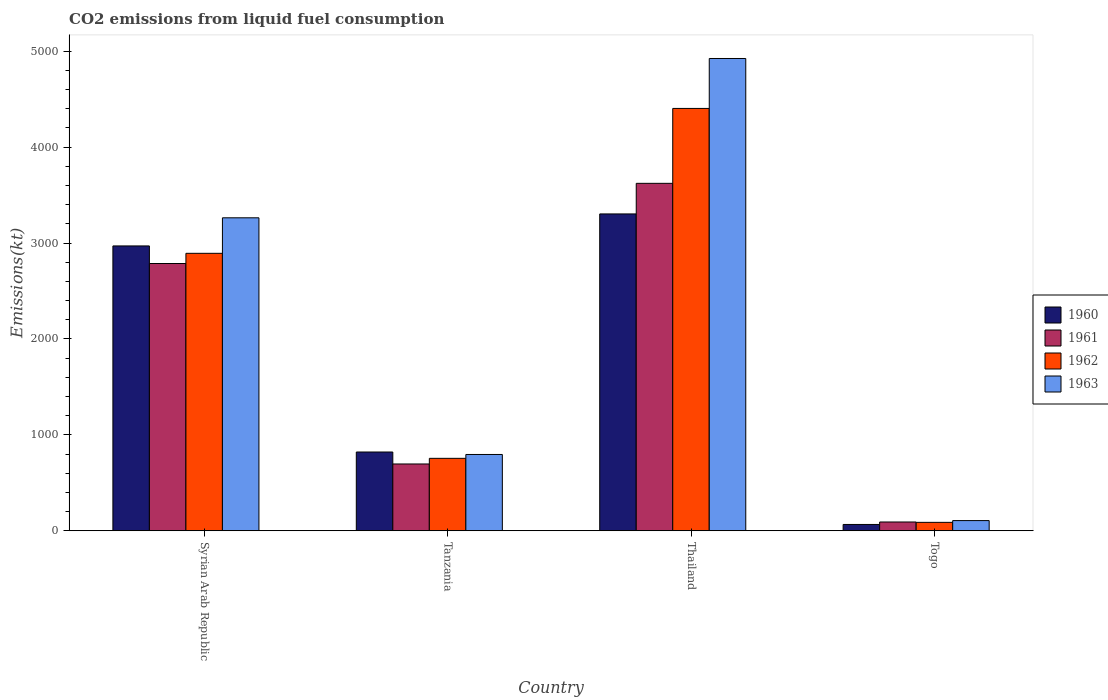How many different coloured bars are there?
Your response must be concise. 4. How many bars are there on the 1st tick from the left?
Your response must be concise. 4. What is the label of the 2nd group of bars from the left?
Provide a succinct answer. Tanzania. In how many cases, is the number of bars for a given country not equal to the number of legend labels?
Your answer should be very brief. 0. What is the amount of CO2 emitted in 1962 in Syrian Arab Republic?
Give a very brief answer. 2893.26. Across all countries, what is the maximum amount of CO2 emitted in 1963?
Your answer should be very brief. 4924.78. Across all countries, what is the minimum amount of CO2 emitted in 1962?
Make the answer very short. 88.01. In which country was the amount of CO2 emitted in 1960 maximum?
Provide a short and direct response. Thailand. In which country was the amount of CO2 emitted in 1962 minimum?
Make the answer very short. Togo. What is the total amount of CO2 emitted in 1960 in the graph?
Provide a succinct answer. 7161.65. What is the difference between the amount of CO2 emitted in 1961 in Syrian Arab Republic and that in Tanzania?
Provide a succinct answer. 2090.19. What is the difference between the amount of CO2 emitted in 1962 in Tanzania and the amount of CO2 emitted in 1963 in Syrian Arab Republic?
Offer a very short reply. -2508.23. What is the average amount of CO2 emitted in 1960 per country?
Offer a terse response. 1790.41. What is the difference between the amount of CO2 emitted of/in 1962 and amount of CO2 emitted of/in 1963 in Thailand?
Ensure brevity in your answer.  -520.71. In how many countries, is the amount of CO2 emitted in 1963 greater than 4000 kt?
Give a very brief answer. 1. What is the ratio of the amount of CO2 emitted in 1960 in Tanzania to that in Togo?
Offer a terse response. 12.44. Is the amount of CO2 emitted in 1961 in Syrian Arab Republic less than that in Thailand?
Your answer should be compact. Yes. What is the difference between the highest and the second highest amount of CO2 emitted in 1962?
Offer a very short reply. -3648.66. What is the difference between the highest and the lowest amount of CO2 emitted in 1961?
Offer a very short reply. 3531.32. What does the 4th bar from the left in Tanzania represents?
Keep it short and to the point. 1963. What is the difference between two consecutive major ticks on the Y-axis?
Provide a succinct answer. 1000. Are the values on the major ticks of Y-axis written in scientific E-notation?
Give a very brief answer. No. Does the graph contain any zero values?
Offer a very short reply. No. Where does the legend appear in the graph?
Your answer should be compact. Center right. How are the legend labels stacked?
Your answer should be very brief. Vertical. What is the title of the graph?
Your response must be concise. CO2 emissions from liquid fuel consumption. What is the label or title of the Y-axis?
Your answer should be compact. Emissions(kt). What is the Emissions(kt) of 1960 in Syrian Arab Republic?
Keep it short and to the point. 2970.27. What is the Emissions(kt) in 1961 in Syrian Arab Republic?
Ensure brevity in your answer.  2786.92. What is the Emissions(kt) in 1962 in Syrian Arab Republic?
Keep it short and to the point. 2893.26. What is the Emissions(kt) in 1963 in Syrian Arab Republic?
Offer a terse response. 3263.63. What is the Emissions(kt) of 1960 in Tanzania?
Offer a terse response. 821.41. What is the Emissions(kt) in 1961 in Tanzania?
Offer a terse response. 696.73. What is the Emissions(kt) of 1962 in Tanzania?
Offer a terse response. 755.4. What is the Emissions(kt) in 1963 in Tanzania?
Provide a short and direct response. 795.74. What is the Emissions(kt) in 1960 in Thailand?
Offer a terse response. 3303.97. What is the Emissions(kt) in 1961 in Thailand?
Keep it short and to the point. 3623. What is the Emissions(kt) of 1962 in Thailand?
Provide a short and direct response. 4404.07. What is the Emissions(kt) in 1963 in Thailand?
Keep it short and to the point. 4924.78. What is the Emissions(kt) of 1960 in Togo?
Your answer should be very brief. 66.01. What is the Emissions(kt) of 1961 in Togo?
Make the answer very short. 91.67. What is the Emissions(kt) in 1962 in Togo?
Your answer should be compact. 88.01. What is the Emissions(kt) in 1963 in Togo?
Offer a terse response. 106.34. Across all countries, what is the maximum Emissions(kt) in 1960?
Keep it short and to the point. 3303.97. Across all countries, what is the maximum Emissions(kt) of 1961?
Give a very brief answer. 3623. Across all countries, what is the maximum Emissions(kt) in 1962?
Offer a terse response. 4404.07. Across all countries, what is the maximum Emissions(kt) in 1963?
Make the answer very short. 4924.78. Across all countries, what is the minimum Emissions(kt) in 1960?
Make the answer very short. 66.01. Across all countries, what is the minimum Emissions(kt) of 1961?
Offer a terse response. 91.67. Across all countries, what is the minimum Emissions(kt) of 1962?
Make the answer very short. 88.01. Across all countries, what is the minimum Emissions(kt) of 1963?
Offer a very short reply. 106.34. What is the total Emissions(kt) of 1960 in the graph?
Make the answer very short. 7161.65. What is the total Emissions(kt) of 1961 in the graph?
Make the answer very short. 7198.32. What is the total Emissions(kt) of 1962 in the graph?
Provide a succinct answer. 8140.74. What is the total Emissions(kt) in 1963 in the graph?
Offer a terse response. 9090.49. What is the difference between the Emissions(kt) of 1960 in Syrian Arab Republic and that in Tanzania?
Your answer should be very brief. 2148.86. What is the difference between the Emissions(kt) in 1961 in Syrian Arab Republic and that in Tanzania?
Ensure brevity in your answer.  2090.19. What is the difference between the Emissions(kt) of 1962 in Syrian Arab Republic and that in Tanzania?
Your response must be concise. 2137.86. What is the difference between the Emissions(kt) in 1963 in Syrian Arab Republic and that in Tanzania?
Your answer should be very brief. 2467.89. What is the difference between the Emissions(kt) in 1960 in Syrian Arab Republic and that in Thailand?
Ensure brevity in your answer.  -333.7. What is the difference between the Emissions(kt) in 1961 in Syrian Arab Republic and that in Thailand?
Provide a short and direct response. -836.08. What is the difference between the Emissions(kt) of 1962 in Syrian Arab Republic and that in Thailand?
Offer a very short reply. -1510.8. What is the difference between the Emissions(kt) of 1963 in Syrian Arab Republic and that in Thailand?
Keep it short and to the point. -1661.15. What is the difference between the Emissions(kt) of 1960 in Syrian Arab Republic and that in Togo?
Provide a succinct answer. 2904.26. What is the difference between the Emissions(kt) of 1961 in Syrian Arab Republic and that in Togo?
Your answer should be very brief. 2695.24. What is the difference between the Emissions(kt) in 1962 in Syrian Arab Republic and that in Togo?
Keep it short and to the point. 2805.26. What is the difference between the Emissions(kt) of 1963 in Syrian Arab Republic and that in Togo?
Your answer should be compact. 3157.29. What is the difference between the Emissions(kt) in 1960 in Tanzania and that in Thailand?
Provide a succinct answer. -2482.56. What is the difference between the Emissions(kt) of 1961 in Tanzania and that in Thailand?
Keep it short and to the point. -2926.27. What is the difference between the Emissions(kt) of 1962 in Tanzania and that in Thailand?
Provide a short and direct response. -3648.66. What is the difference between the Emissions(kt) in 1963 in Tanzania and that in Thailand?
Offer a terse response. -4129.04. What is the difference between the Emissions(kt) in 1960 in Tanzania and that in Togo?
Keep it short and to the point. 755.4. What is the difference between the Emissions(kt) of 1961 in Tanzania and that in Togo?
Provide a succinct answer. 605.05. What is the difference between the Emissions(kt) of 1962 in Tanzania and that in Togo?
Keep it short and to the point. 667.39. What is the difference between the Emissions(kt) in 1963 in Tanzania and that in Togo?
Your answer should be compact. 689.4. What is the difference between the Emissions(kt) of 1960 in Thailand and that in Togo?
Make the answer very short. 3237.96. What is the difference between the Emissions(kt) of 1961 in Thailand and that in Togo?
Your answer should be compact. 3531.32. What is the difference between the Emissions(kt) in 1962 in Thailand and that in Togo?
Your answer should be very brief. 4316.06. What is the difference between the Emissions(kt) of 1963 in Thailand and that in Togo?
Ensure brevity in your answer.  4818.44. What is the difference between the Emissions(kt) in 1960 in Syrian Arab Republic and the Emissions(kt) in 1961 in Tanzania?
Offer a terse response. 2273.54. What is the difference between the Emissions(kt) in 1960 in Syrian Arab Republic and the Emissions(kt) in 1962 in Tanzania?
Offer a very short reply. 2214.87. What is the difference between the Emissions(kt) of 1960 in Syrian Arab Republic and the Emissions(kt) of 1963 in Tanzania?
Offer a terse response. 2174.53. What is the difference between the Emissions(kt) in 1961 in Syrian Arab Republic and the Emissions(kt) in 1962 in Tanzania?
Provide a succinct answer. 2031.52. What is the difference between the Emissions(kt) in 1961 in Syrian Arab Republic and the Emissions(kt) in 1963 in Tanzania?
Provide a succinct answer. 1991.18. What is the difference between the Emissions(kt) in 1962 in Syrian Arab Republic and the Emissions(kt) in 1963 in Tanzania?
Ensure brevity in your answer.  2097.52. What is the difference between the Emissions(kt) of 1960 in Syrian Arab Republic and the Emissions(kt) of 1961 in Thailand?
Keep it short and to the point. -652.73. What is the difference between the Emissions(kt) of 1960 in Syrian Arab Republic and the Emissions(kt) of 1962 in Thailand?
Your response must be concise. -1433.8. What is the difference between the Emissions(kt) in 1960 in Syrian Arab Republic and the Emissions(kt) in 1963 in Thailand?
Provide a short and direct response. -1954.51. What is the difference between the Emissions(kt) of 1961 in Syrian Arab Republic and the Emissions(kt) of 1962 in Thailand?
Ensure brevity in your answer.  -1617.15. What is the difference between the Emissions(kt) of 1961 in Syrian Arab Republic and the Emissions(kt) of 1963 in Thailand?
Offer a very short reply. -2137.86. What is the difference between the Emissions(kt) of 1962 in Syrian Arab Republic and the Emissions(kt) of 1963 in Thailand?
Make the answer very short. -2031.52. What is the difference between the Emissions(kt) in 1960 in Syrian Arab Republic and the Emissions(kt) in 1961 in Togo?
Offer a very short reply. 2878.59. What is the difference between the Emissions(kt) in 1960 in Syrian Arab Republic and the Emissions(kt) in 1962 in Togo?
Offer a terse response. 2882.26. What is the difference between the Emissions(kt) of 1960 in Syrian Arab Republic and the Emissions(kt) of 1963 in Togo?
Provide a succinct answer. 2863.93. What is the difference between the Emissions(kt) in 1961 in Syrian Arab Republic and the Emissions(kt) in 1962 in Togo?
Ensure brevity in your answer.  2698.91. What is the difference between the Emissions(kt) in 1961 in Syrian Arab Republic and the Emissions(kt) in 1963 in Togo?
Provide a succinct answer. 2680.58. What is the difference between the Emissions(kt) in 1962 in Syrian Arab Republic and the Emissions(kt) in 1963 in Togo?
Give a very brief answer. 2786.92. What is the difference between the Emissions(kt) of 1960 in Tanzania and the Emissions(kt) of 1961 in Thailand?
Provide a succinct answer. -2801.59. What is the difference between the Emissions(kt) of 1960 in Tanzania and the Emissions(kt) of 1962 in Thailand?
Provide a succinct answer. -3582.66. What is the difference between the Emissions(kt) in 1960 in Tanzania and the Emissions(kt) in 1963 in Thailand?
Give a very brief answer. -4103.37. What is the difference between the Emissions(kt) of 1961 in Tanzania and the Emissions(kt) of 1962 in Thailand?
Keep it short and to the point. -3707.34. What is the difference between the Emissions(kt) of 1961 in Tanzania and the Emissions(kt) of 1963 in Thailand?
Offer a terse response. -4228.05. What is the difference between the Emissions(kt) in 1962 in Tanzania and the Emissions(kt) in 1963 in Thailand?
Keep it short and to the point. -4169.38. What is the difference between the Emissions(kt) of 1960 in Tanzania and the Emissions(kt) of 1961 in Togo?
Offer a terse response. 729.73. What is the difference between the Emissions(kt) in 1960 in Tanzania and the Emissions(kt) in 1962 in Togo?
Offer a very short reply. 733.4. What is the difference between the Emissions(kt) of 1960 in Tanzania and the Emissions(kt) of 1963 in Togo?
Ensure brevity in your answer.  715.07. What is the difference between the Emissions(kt) of 1961 in Tanzania and the Emissions(kt) of 1962 in Togo?
Provide a short and direct response. 608.72. What is the difference between the Emissions(kt) in 1961 in Tanzania and the Emissions(kt) in 1963 in Togo?
Ensure brevity in your answer.  590.39. What is the difference between the Emissions(kt) of 1962 in Tanzania and the Emissions(kt) of 1963 in Togo?
Provide a succinct answer. 649.06. What is the difference between the Emissions(kt) in 1960 in Thailand and the Emissions(kt) in 1961 in Togo?
Your answer should be compact. 3212.29. What is the difference between the Emissions(kt) in 1960 in Thailand and the Emissions(kt) in 1962 in Togo?
Offer a very short reply. 3215.96. What is the difference between the Emissions(kt) in 1960 in Thailand and the Emissions(kt) in 1963 in Togo?
Your answer should be compact. 3197.62. What is the difference between the Emissions(kt) of 1961 in Thailand and the Emissions(kt) of 1962 in Togo?
Make the answer very short. 3534.99. What is the difference between the Emissions(kt) in 1961 in Thailand and the Emissions(kt) in 1963 in Togo?
Provide a succinct answer. 3516.65. What is the difference between the Emissions(kt) of 1962 in Thailand and the Emissions(kt) of 1963 in Togo?
Your answer should be compact. 4297.72. What is the average Emissions(kt) of 1960 per country?
Provide a succinct answer. 1790.41. What is the average Emissions(kt) of 1961 per country?
Keep it short and to the point. 1799.58. What is the average Emissions(kt) of 1962 per country?
Your answer should be very brief. 2035.18. What is the average Emissions(kt) in 1963 per country?
Keep it short and to the point. 2272.62. What is the difference between the Emissions(kt) in 1960 and Emissions(kt) in 1961 in Syrian Arab Republic?
Your answer should be very brief. 183.35. What is the difference between the Emissions(kt) of 1960 and Emissions(kt) of 1962 in Syrian Arab Republic?
Make the answer very short. 77.01. What is the difference between the Emissions(kt) of 1960 and Emissions(kt) of 1963 in Syrian Arab Republic?
Give a very brief answer. -293.36. What is the difference between the Emissions(kt) in 1961 and Emissions(kt) in 1962 in Syrian Arab Republic?
Offer a terse response. -106.34. What is the difference between the Emissions(kt) of 1961 and Emissions(kt) of 1963 in Syrian Arab Republic?
Keep it short and to the point. -476.71. What is the difference between the Emissions(kt) in 1962 and Emissions(kt) in 1963 in Syrian Arab Republic?
Offer a very short reply. -370.37. What is the difference between the Emissions(kt) in 1960 and Emissions(kt) in 1961 in Tanzania?
Provide a succinct answer. 124.68. What is the difference between the Emissions(kt) in 1960 and Emissions(kt) in 1962 in Tanzania?
Make the answer very short. 66.01. What is the difference between the Emissions(kt) of 1960 and Emissions(kt) of 1963 in Tanzania?
Your response must be concise. 25.67. What is the difference between the Emissions(kt) in 1961 and Emissions(kt) in 1962 in Tanzania?
Make the answer very short. -58.67. What is the difference between the Emissions(kt) of 1961 and Emissions(kt) of 1963 in Tanzania?
Your response must be concise. -99.01. What is the difference between the Emissions(kt) in 1962 and Emissions(kt) in 1963 in Tanzania?
Keep it short and to the point. -40.34. What is the difference between the Emissions(kt) of 1960 and Emissions(kt) of 1961 in Thailand?
Make the answer very short. -319.03. What is the difference between the Emissions(kt) in 1960 and Emissions(kt) in 1962 in Thailand?
Offer a very short reply. -1100.1. What is the difference between the Emissions(kt) in 1960 and Emissions(kt) in 1963 in Thailand?
Your answer should be compact. -1620.81. What is the difference between the Emissions(kt) in 1961 and Emissions(kt) in 1962 in Thailand?
Your answer should be very brief. -781.07. What is the difference between the Emissions(kt) in 1961 and Emissions(kt) in 1963 in Thailand?
Your answer should be very brief. -1301.79. What is the difference between the Emissions(kt) of 1962 and Emissions(kt) of 1963 in Thailand?
Your answer should be very brief. -520.71. What is the difference between the Emissions(kt) of 1960 and Emissions(kt) of 1961 in Togo?
Ensure brevity in your answer.  -25.67. What is the difference between the Emissions(kt) in 1960 and Emissions(kt) in 1962 in Togo?
Provide a succinct answer. -22. What is the difference between the Emissions(kt) in 1960 and Emissions(kt) in 1963 in Togo?
Your response must be concise. -40.34. What is the difference between the Emissions(kt) in 1961 and Emissions(kt) in 1962 in Togo?
Give a very brief answer. 3.67. What is the difference between the Emissions(kt) in 1961 and Emissions(kt) in 1963 in Togo?
Your answer should be compact. -14.67. What is the difference between the Emissions(kt) in 1962 and Emissions(kt) in 1963 in Togo?
Your response must be concise. -18.34. What is the ratio of the Emissions(kt) of 1960 in Syrian Arab Republic to that in Tanzania?
Offer a terse response. 3.62. What is the ratio of the Emissions(kt) in 1962 in Syrian Arab Republic to that in Tanzania?
Keep it short and to the point. 3.83. What is the ratio of the Emissions(kt) of 1963 in Syrian Arab Republic to that in Tanzania?
Keep it short and to the point. 4.1. What is the ratio of the Emissions(kt) of 1960 in Syrian Arab Republic to that in Thailand?
Your answer should be very brief. 0.9. What is the ratio of the Emissions(kt) of 1961 in Syrian Arab Republic to that in Thailand?
Ensure brevity in your answer.  0.77. What is the ratio of the Emissions(kt) in 1962 in Syrian Arab Republic to that in Thailand?
Keep it short and to the point. 0.66. What is the ratio of the Emissions(kt) in 1963 in Syrian Arab Republic to that in Thailand?
Offer a very short reply. 0.66. What is the ratio of the Emissions(kt) in 1961 in Syrian Arab Republic to that in Togo?
Provide a short and direct response. 30.4. What is the ratio of the Emissions(kt) of 1962 in Syrian Arab Republic to that in Togo?
Give a very brief answer. 32.88. What is the ratio of the Emissions(kt) of 1963 in Syrian Arab Republic to that in Togo?
Provide a short and direct response. 30.69. What is the ratio of the Emissions(kt) in 1960 in Tanzania to that in Thailand?
Your response must be concise. 0.25. What is the ratio of the Emissions(kt) in 1961 in Tanzania to that in Thailand?
Your answer should be very brief. 0.19. What is the ratio of the Emissions(kt) of 1962 in Tanzania to that in Thailand?
Make the answer very short. 0.17. What is the ratio of the Emissions(kt) in 1963 in Tanzania to that in Thailand?
Offer a terse response. 0.16. What is the ratio of the Emissions(kt) of 1960 in Tanzania to that in Togo?
Keep it short and to the point. 12.44. What is the ratio of the Emissions(kt) in 1961 in Tanzania to that in Togo?
Your answer should be very brief. 7.6. What is the ratio of the Emissions(kt) of 1962 in Tanzania to that in Togo?
Give a very brief answer. 8.58. What is the ratio of the Emissions(kt) in 1963 in Tanzania to that in Togo?
Your answer should be very brief. 7.48. What is the ratio of the Emissions(kt) of 1960 in Thailand to that in Togo?
Provide a short and direct response. 50.06. What is the ratio of the Emissions(kt) of 1961 in Thailand to that in Togo?
Your response must be concise. 39.52. What is the ratio of the Emissions(kt) in 1962 in Thailand to that in Togo?
Provide a short and direct response. 50.04. What is the ratio of the Emissions(kt) in 1963 in Thailand to that in Togo?
Make the answer very short. 46.31. What is the difference between the highest and the second highest Emissions(kt) in 1960?
Offer a terse response. 333.7. What is the difference between the highest and the second highest Emissions(kt) in 1961?
Your answer should be very brief. 836.08. What is the difference between the highest and the second highest Emissions(kt) in 1962?
Offer a very short reply. 1510.8. What is the difference between the highest and the second highest Emissions(kt) of 1963?
Your response must be concise. 1661.15. What is the difference between the highest and the lowest Emissions(kt) of 1960?
Your answer should be very brief. 3237.96. What is the difference between the highest and the lowest Emissions(kt) in 1961?
Keep it short and to the point. 3531.32. What is the difference between the highest and the lowest Emissions(kt) of 1962?
Offer a terse response. 4316.06. What is the difference between the highest and the lowest Emissions(kt) of 1963?
Your response must be concise. 4818.44. 